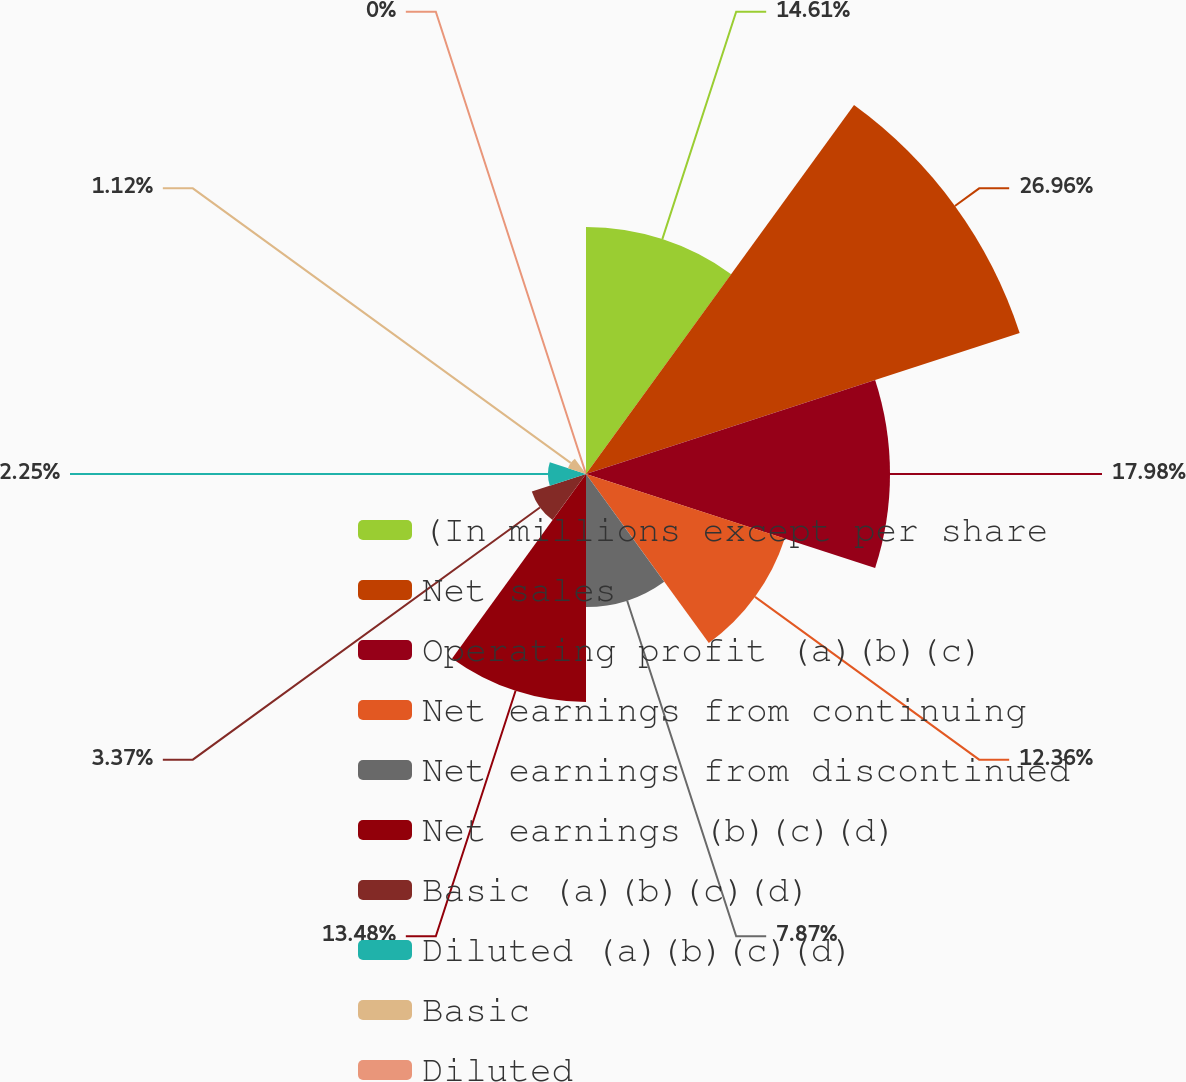Convert chart. <chart><loc_0><loc_0><loc_500><loc_500><pie_chart><fcel>(In millions except per share<fcel>Net sales<fcel>Operating profit (a)(b)(c)<fcel>Net earnings from continuing<fcel>Net earnings from discontinued<fcel>Net earnings (b)(c)(d)<fcel>Basic (a)(b)(c)(d)<fcel>Diluted (a)(b)(c)(d)<fcel>Basic<fcel>Diluted<nl><fcel>14.61%<fcel>26.97%<fcel>17.98%<fcel>12.36%<fcel>7.87%<fcel>13.48%<fcel>3.37%<fcel>2.25%<fcel>1.12%<fcel>0.0%<nl></chart> 